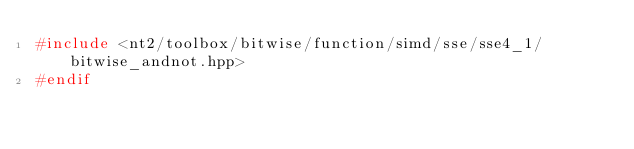Convert code to text. <code><loc_0><loc_0><loc_500><loc_500><_C++_>#include <nt2/toolbox/bitwise/function/simd/sse/sse4_1/bitwise_andnot.hpp>
#endif
</code> 